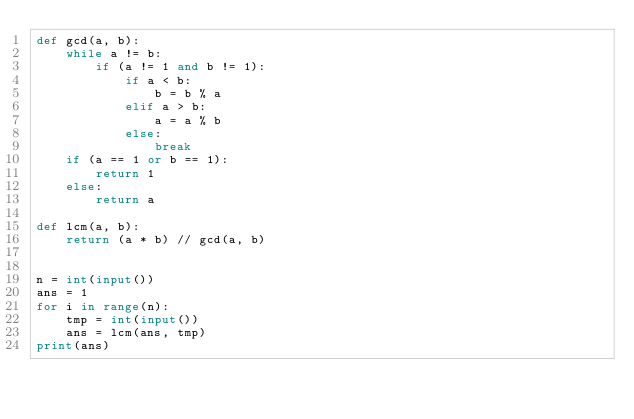Convert code to text. <code><loc_0><loc_0><loc_500><loc_500><_Python_>def gcd(a, b):
    while a != b:
        if (a != 1 and b != 1):
            if a < b:
                b = b % a
            elif a > b:
                a = a % b
            else:
                break
    if (a == 1 or b == 1):
        return 1
    else:
        return a

def lcm(a, b):
    return (a * b) // gcd(a, b)


n = int(input())
ans = 1
for i in range(n):
    tmp = int(input())
    ans = lcm(ans, tmp)
print(ans)
</code> 